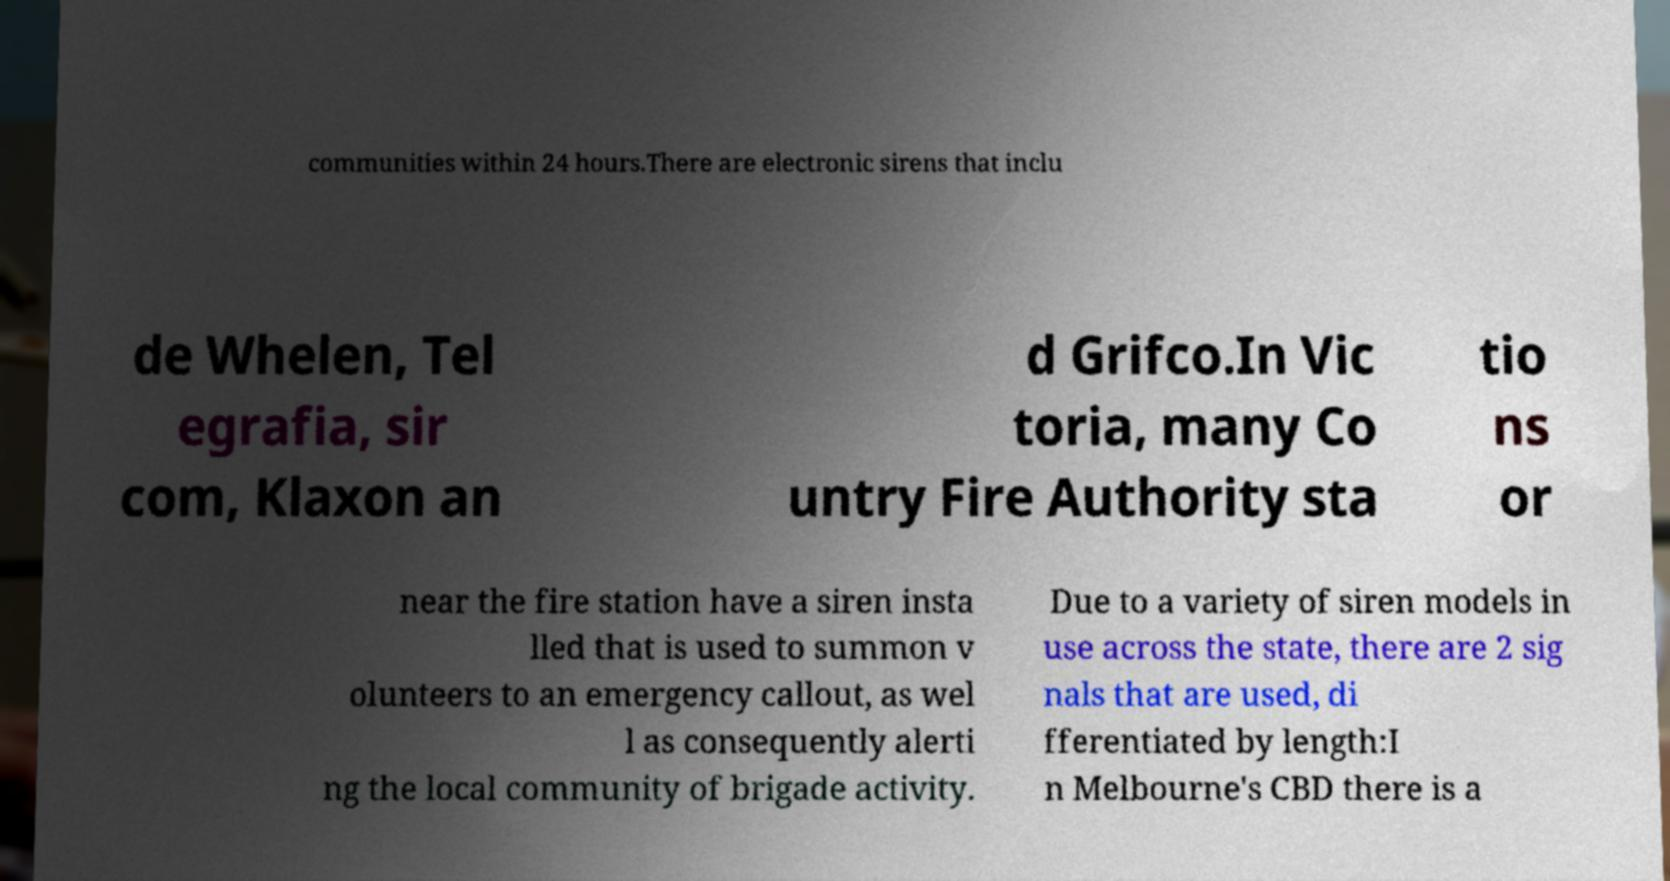For documentation purposes, I need the text within this image transcribed. Could you provide that? communities within 24 hours.There are electronic sirens that inclu de Whelen, Tel egrafia, sir com, Klaxon an d Grifco.In Vic toria, many Co untry Fire Authority sta tio ns or near the fire station have a siren insta lled that is used to summon v olunteers to an emergency callout, as wel l as consequently alerti ng the local community of brigade activity. Due to a variety of siren models in use across the state, there are 2 sig nals that are used, di fferentiated by length:I n Melbourne's CBD there is a 